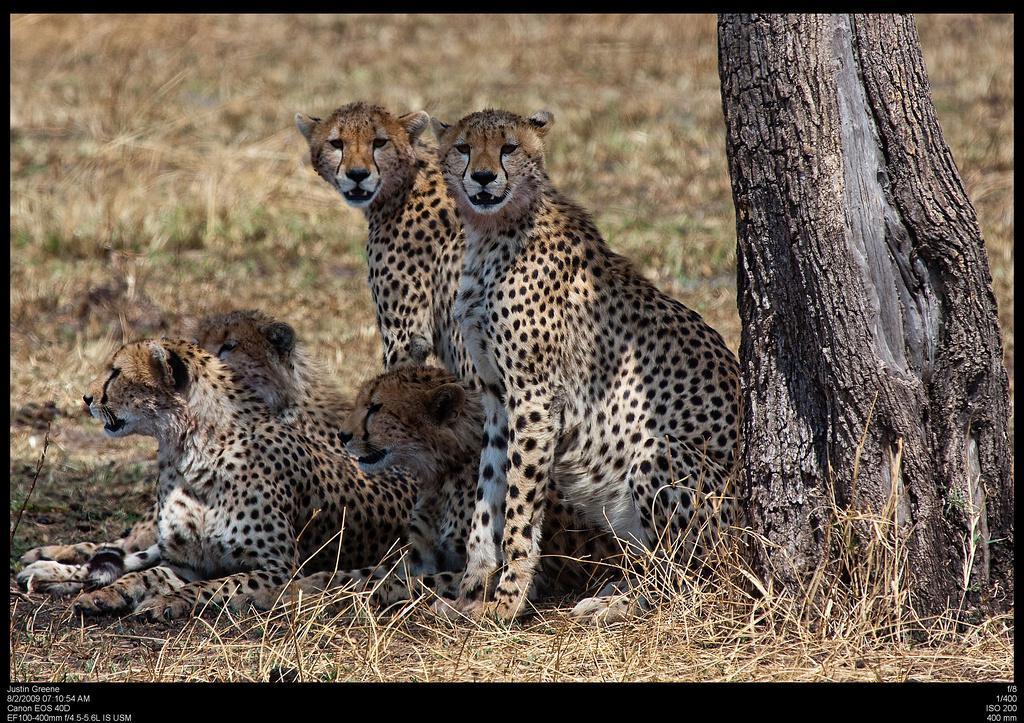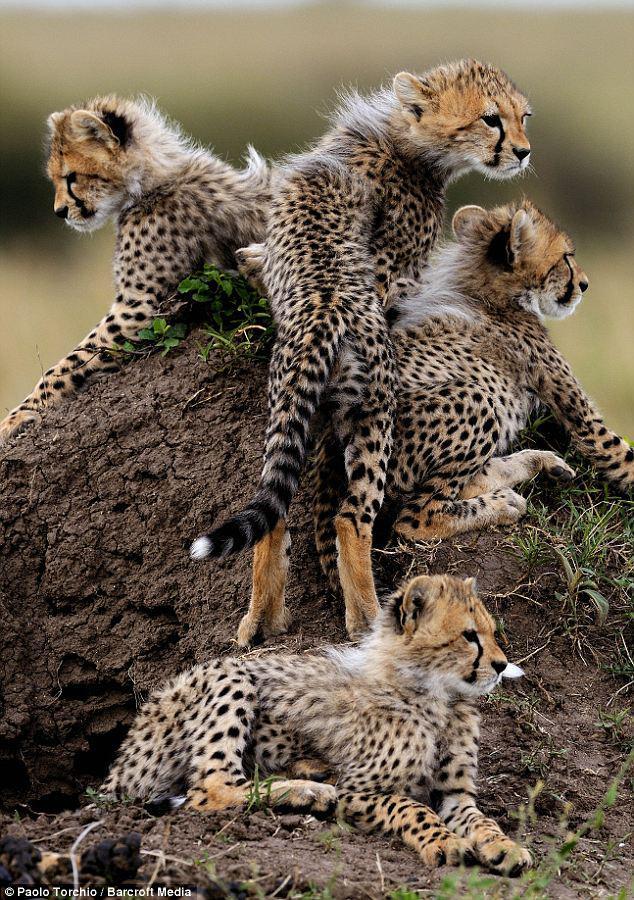The first image is the image on the left, the second image is the image on the right. Given the left and right images, does the statement "There are no more than 2 cheetas in the right image." hold true? Answer yes or no. No. The first image is the image on the left, the second image is the image on the right. Analyze the images presented: Is the assertion "There are no more than two cheetahs in the right image." valid? Answer yes or no. No. 